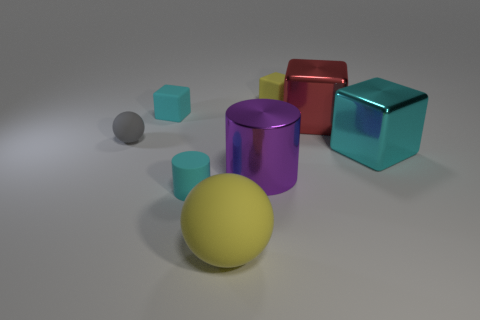What is the shape of the big shiny thing that is the same color as the small cylinder?
Offer a terse response. Cube. Do the cyan rubber object that is behind the cyan shiny block and the small gray matte thing have the same size?
Provide a succinct answer. Yes. What is the shape of the red object that is the same size as the purple thing?
Provide a short and direct response. Cube. Do the red shiny object and the large cyan metallic object have the same shape?
Offer a terse response. Yes. How many cyan rubber things are the same shape as the gray rubber object?
Keep it short and to the point. 0. There is a small yellow thing; what number of gray things are right of it?
Keep it short and to the point. 0. Is the color of the large metallic block that is in front of the gray thing the same as the rubber cylinder?
Provide a short and direct response. Yes. What number of yellow rubber things have the same size as the cyan rubber cylinder?
Your answer should be very brief. 1. The red thing that is the same material as the large purple object is what shape?
Keep it short and to the point. Cube. Are there any big rubber cubes that have the same color as the large rubber thing?
Your answer should be very brief. No. 